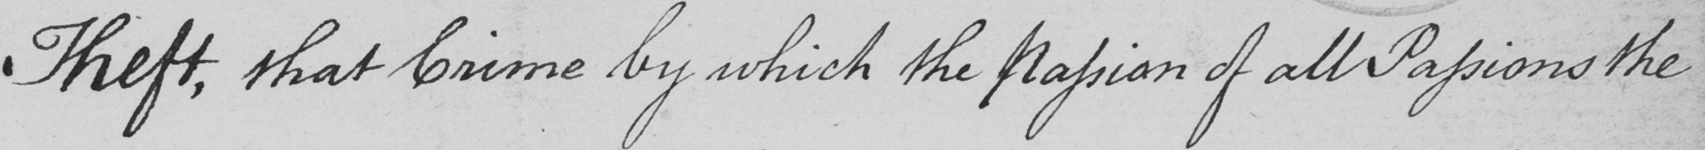Transcribe the text shown in this historical manuscript line. Theft , that Crime by which the Passion of all Passions the 